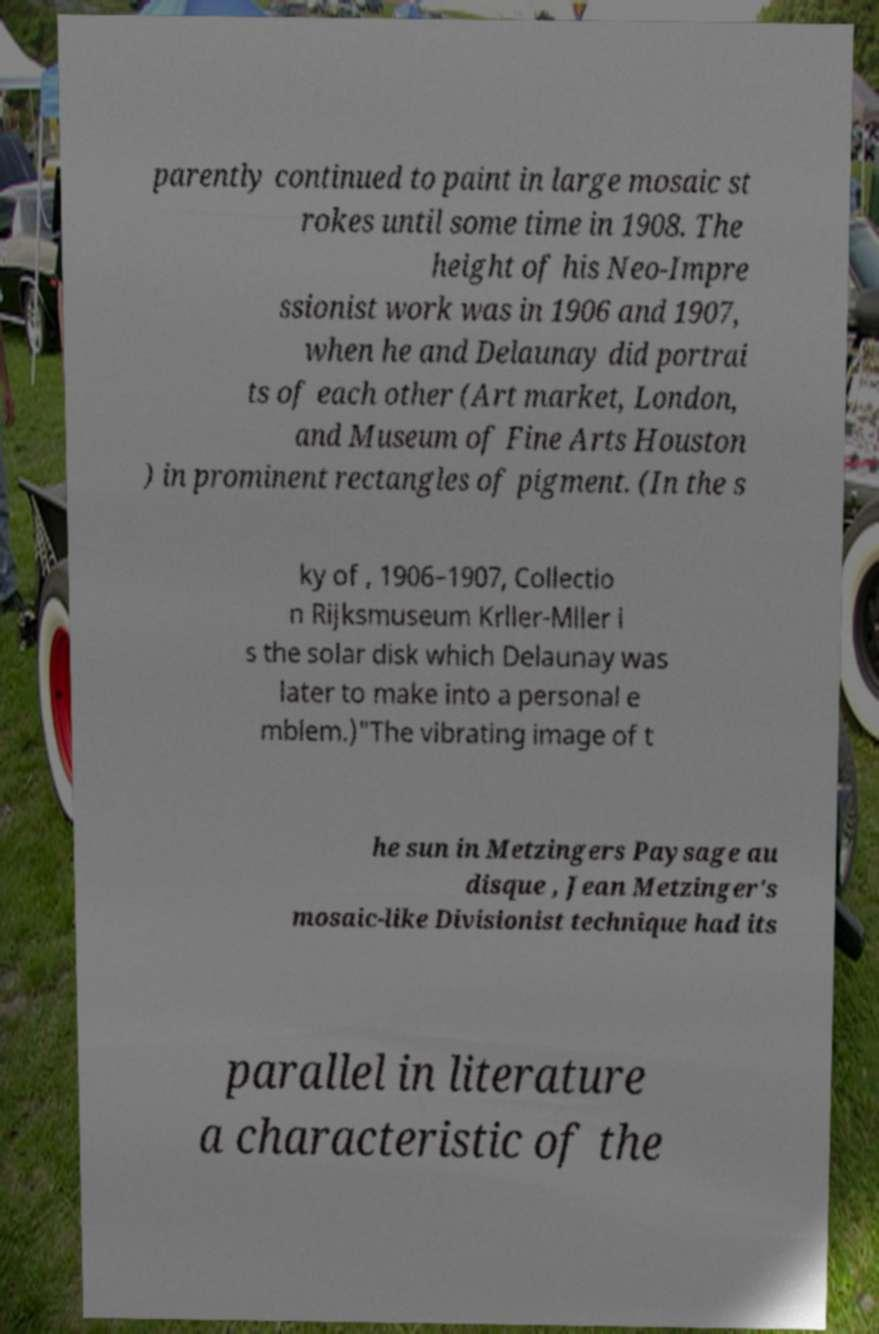Can you accurately transcribe the text from the provided image for me? parently continued to paint in large mosaic st rokes until some time in 1908. The height of his Neo-Impre ssionist work was in 1906 and 1907, when he and Delaunay did portrai ts of each other (Art market, London, and Museum of Fine Arts Houston ) in prominent rectangles of pigment. (In the s ky of , 1906–1907, Collectio n Rijksmuseum Krller-Mller i s the solar disk which Delaunay was later to make into a personal e mblem.)"The vibrating image of t he sun in Metzingers Paysage au disque , Jean Metzinger's mosaic-like Divisionist technique had its parallel in literature a characteristic of the 